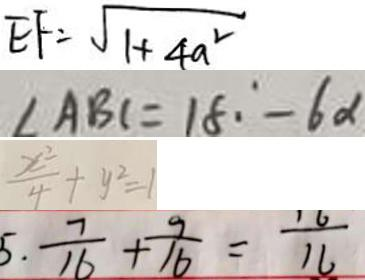<formula> <loc_0><loc_0><loc_500><loc_500>E F = \sqrt { 1 + 4 a ^ { 2 } } 
 \angle A B C = 1 8 \cdot ^ { \circ } - 6 \alpha 
 \frac { x ^ { 2 } } { 4 } + y ^ { 2 } = 1 
 5 . \frac { 7 } { 1 6 } + \frac { 9 } { 1 6 } = \frac { 1 6 } { 1 6 }</formula> 